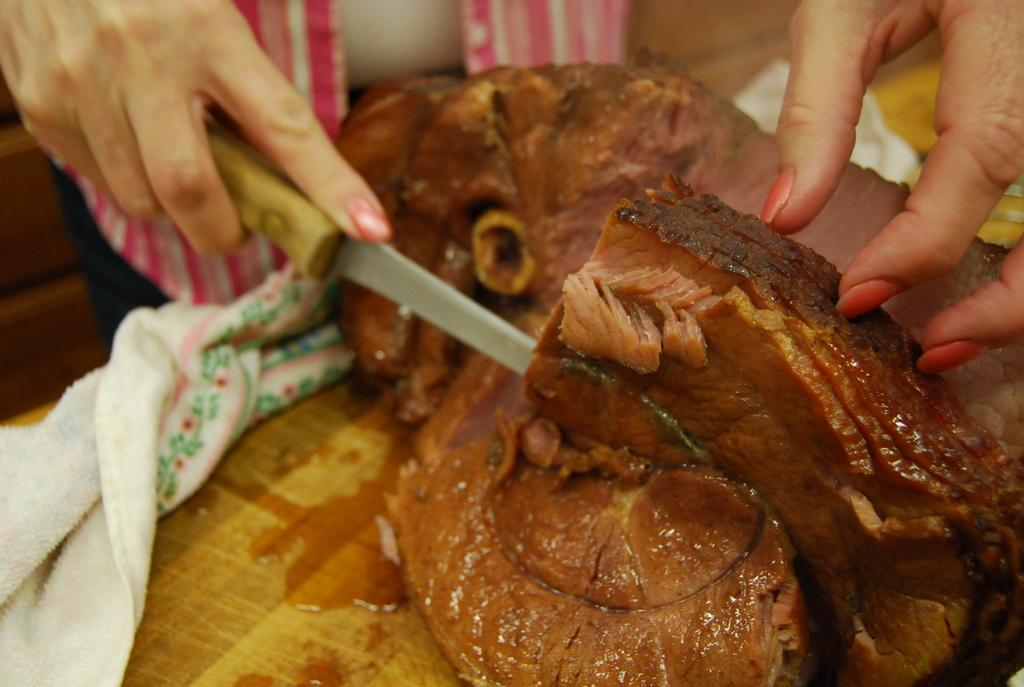What is on the table in the image? There is meat on the table in the image. What is the person in the image doing? The person is holding a knife and cutting the meat. What color is the cloth on the table? The cloth on the table is white. Are there any cobwebs visible on the person cutting the meat in the image? There is no mention of cobwebs in the image, so we cannot determine their presence. 